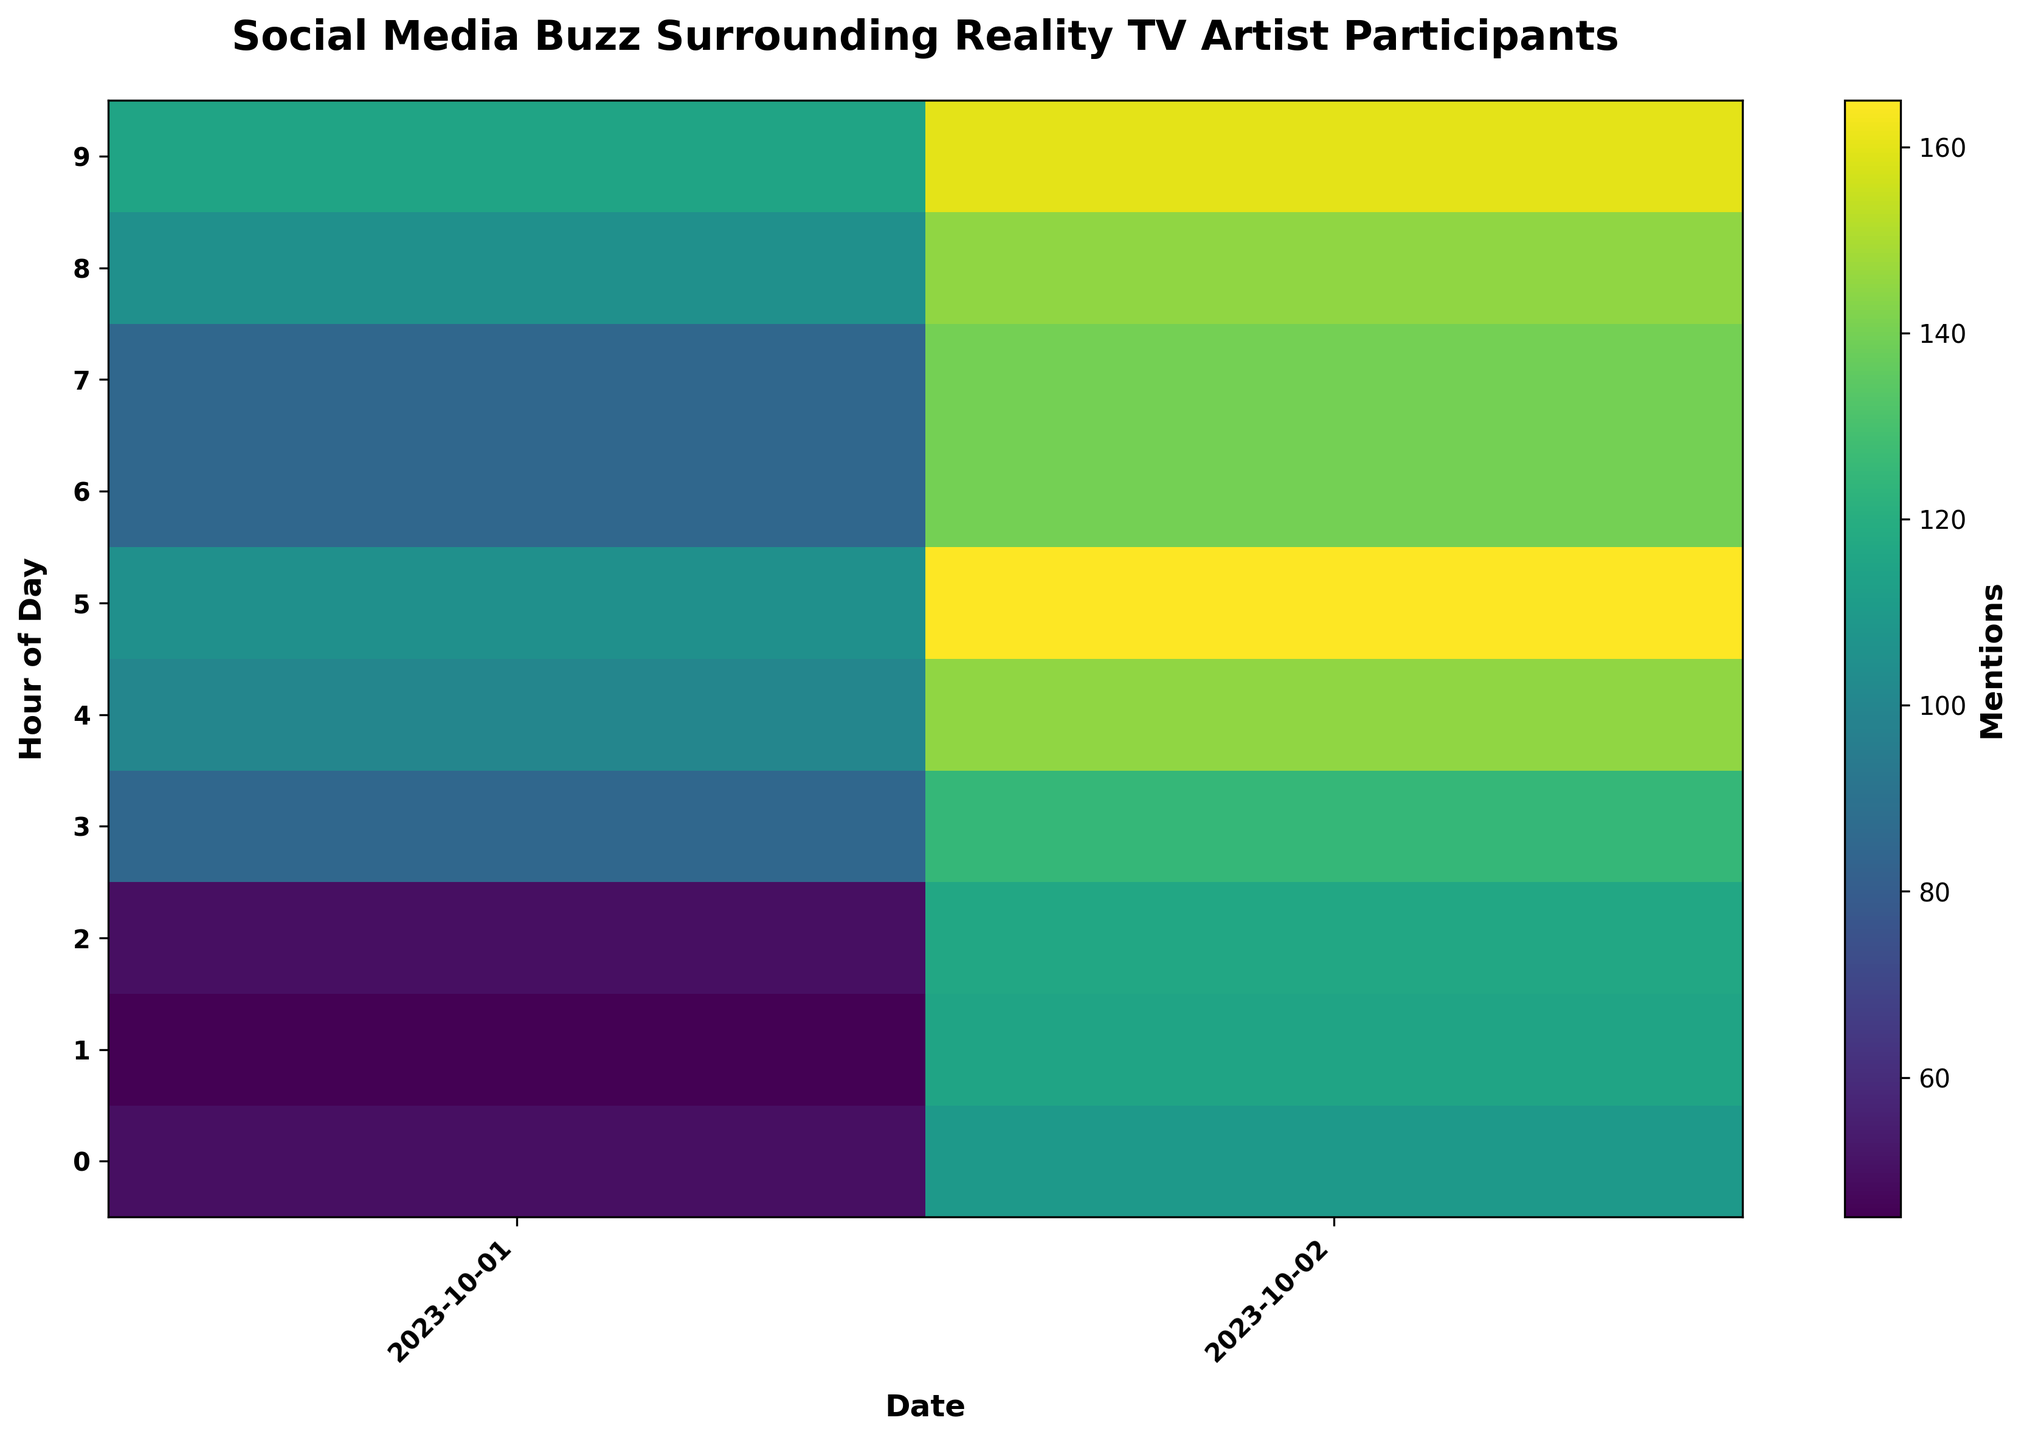Which participant had the highest number of mentions in any given hour? Look for the highest value in the heatmap and identify the participant associated with that hour and date.
Answer: Artist_A During which hours does Artist_B see a significant increase in mentions on 2023-10-02 compared to the previous day? Compare the mention values for Artist_B on 2023-10-01 and 2023-10-02 hour by hour, and identify the hours with a substantial increase.
Answer: 00, 01, 02, 05, 06, 07 What is the average number of mentions for Artist_C on 2023-10-01? Sum the mentions for Artist_C across all hours on 2023-10-01 and divide by the number of hours. Calculation: (10 + 15 + 10 + 25 + 30 + 20 + 10 + 5 + 25 + 30) / 10.
Answer: 18 Which date shows a more uniform distribution of mentions for all participants across different hours? Look for the date where the heatmap's color intensity is more consistent across hours for all participants.
Answer: 2023-10-02 During which hour does Artist_A see the peak mentions on 2023-10-01? Identify the highest value for Artist_A on 2023-10-01 from the heatmap.
Answer: 05 Compare the mention trends of Artist_A and Artist_B for the first three hours of 2023-10-01. Refer to the heatmap colors/intensities for both artists from 00:00 to 02:00 on 2023-10-01 and compare.
Answer: Artist_A trends upward, while Artist_B trends downward What pattern do you observe in social media buzz for Artist_C over the two days? Analyze the heatmap for Artist_C's mentions across both dates and observe if there's a rise, fall, or consistent pattern.
Answer: Consistent with slight increases What is the difference between the highest and lowest mentions for Artist_B on 2023-10-01? Identify the highest and lowest mention values on 2023-10-01 for Artist_B and subtract the lowest from the highest. Calculation: 50 - 5.
Answer: 45 Which hour has the least social media buzz for any participant on 2023-10-02? Find the hour with the lowest mention values for any participant on 2023-10-02.
Answer: 02 for Artist_C 